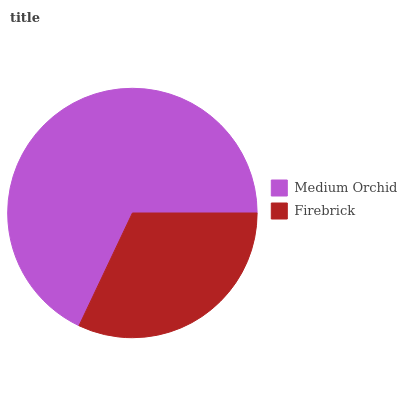Is Firebrick the minimum?
Answer yes or no. Yes. Is Medium Orchid the maximum?
Answer yes or no. Yes. Is Firebrick the maximum?
Answer yes or no. No. Is Medium Orchid greater than Firebrick?
Answer yes or no. Yes. Is Firebrick less than Medium Orchid?
Answer yes or no. Yes. Is Firebrick greater than Medium Orchid?
Answer yes or no. No. Is Medium Orchid less than Firebrick?
Answer yes or no. No. Is Medium Orchid the high median?
Answer yes or no. Yes. Is Firebrick the low median?
Answer yes or no. Yes. Is Firebrick the high median?
Answer yes or no. No. Is Medium Orchid the low median?
Answer yes or no. No. 